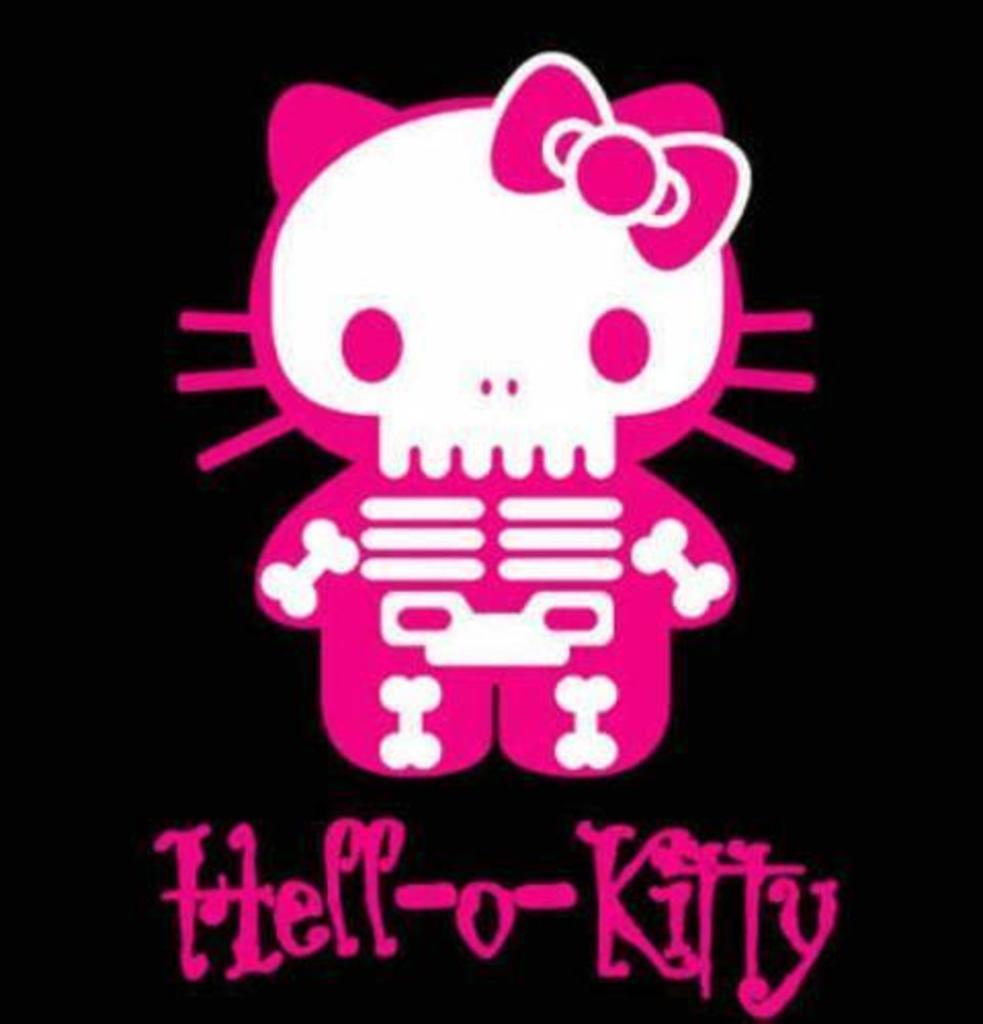What type of image is being described? The image is an animation. What can be seen in the animation? There is a cartoon character in the image. Is there any text present in the animation? Yes, there is text at the bottom of the image. How many mailboxes are visible in the animation? There are no mailboxes visible in the animation; it features a cartoon character and text. What type of body is shown in the animation? The animation is a cartoon, so it does not depict a real human body. 